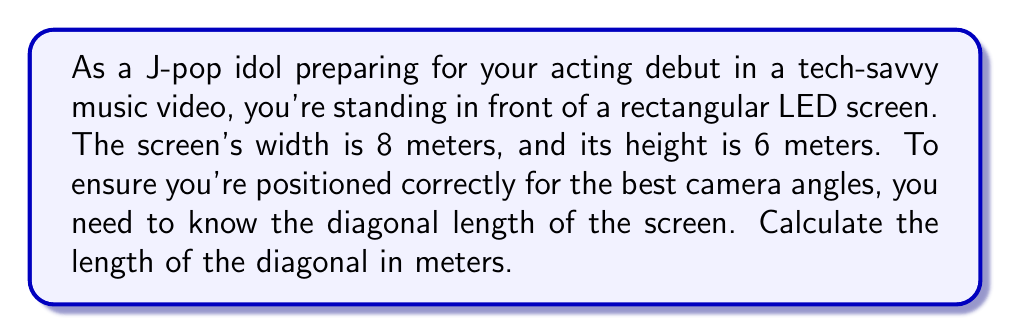Give your solution to this math problem. Let's approach this step-by-step:

1) We can use the Pythagorean theorem to solve this problem. The diagonal of a rectangle forms the hypotenuse of a right triangle, with the width and height forming the other two sides.

2) Let's denote the diagonal as $d$. We know:
   - Width ($w$) = 8 meters
   - Height ($h$) = 6 meters

3) According to the Pythagorean theorem:

   $$ d^2 = w^2 + h^2 $$

4) Substituting our known values:

   $$ d^2 = 8^2 + 6^2 $$

5) Simplify:

   $$ d^2 = 64 + 36 = 100 $$

6) Take the square root of both sides:

   $$ d = \sqrt{100} = 10 $$

7) Therefore, the diagonal length is 10 meters.

[asy]
unitsize(0.5cm);
draw((0,0)--(8,0)--(8,6)--(0,6)--cycle);
draw((0,0)--(8,6),dashed);
label("8m", (4,0), S);
label("6m", (8,3), E);
label("10m", (4,3), NW);
[/asy]
Answer: $10$ meters 